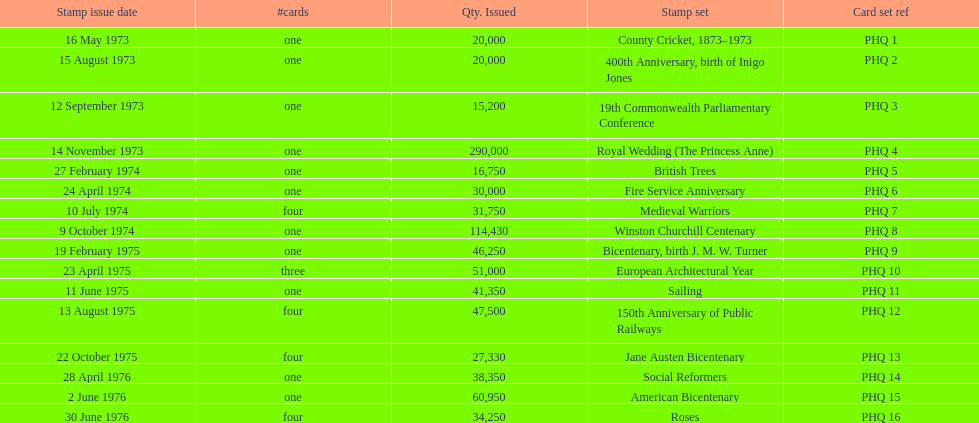Which card was issued most? Royal Wedding (The Princess Anne). 